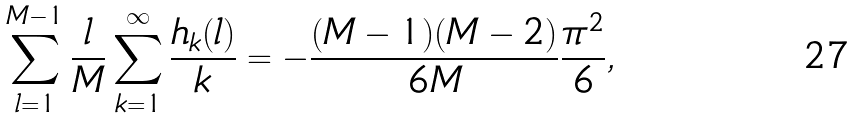<formula> <loc_0><loc_0><loc_500><loc_500>\sum _ { l = 1 } ^ { M - 1 } { \frac { l } { M } } \sum _ { k = 1 } ^ { \infty } { \frac { h _ { k } ( l ) } { k } } = - { \frac { ( M - 1 ) ( M - 2 ) } { 6 M } } { \frac { \pi ^ { 2 } } { 6 } } ,</formula> 